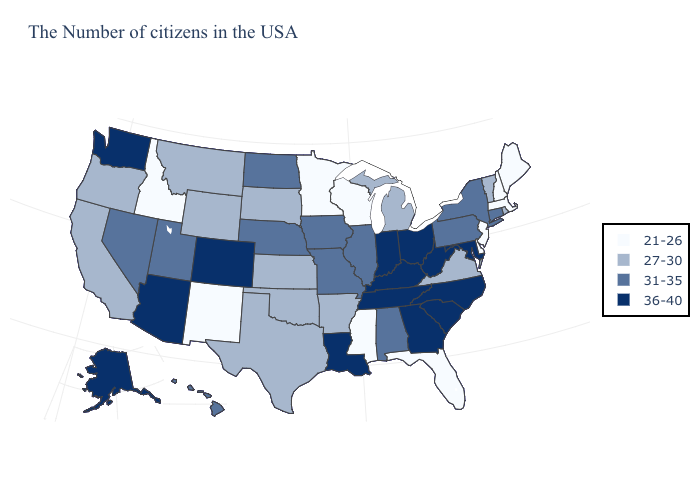What is the value of North Dakota?
Write a very short answer. 31-35. What is the value of Connecticut?
Write a very short answer. 31-35. Name the states that have a value in the range 21-26?
Concise answer only. Maine, Massachusetts, New Hampshire, New Jersey, Delaware, Florida, Wisconsin, Mississippi, Minnesota, New Mexico, Idaho. Does West Virginia have the lowest value in the USA?
Be succinct. No. Among the states that border Michigan , does Wisconsin have the highest value?
Short answer required. No. What is the highest value in the USA?
Short answer required. 36-40. What is the value of Michigan?
Be succinct. 27-30. Does Utah have the highest value in the West?
Short answer required. No. What is the value of Massachusetts?
Short answer required. 21-26. What is the value of California?
Write a very short answer. 27-30. What is the value of South Dakota?
Keep it brief. 27-30. Among the states that border Texas , does Louisiana have the highest value?
Quick response, please. Yes. Which states have the lowest value in the Northeast?
Be succinct. Maine, Massachusetts, New Hampshire, New Jersey. Among the states that border Missouri , does Iowa have the lowest value?
Quick response, please. No. 